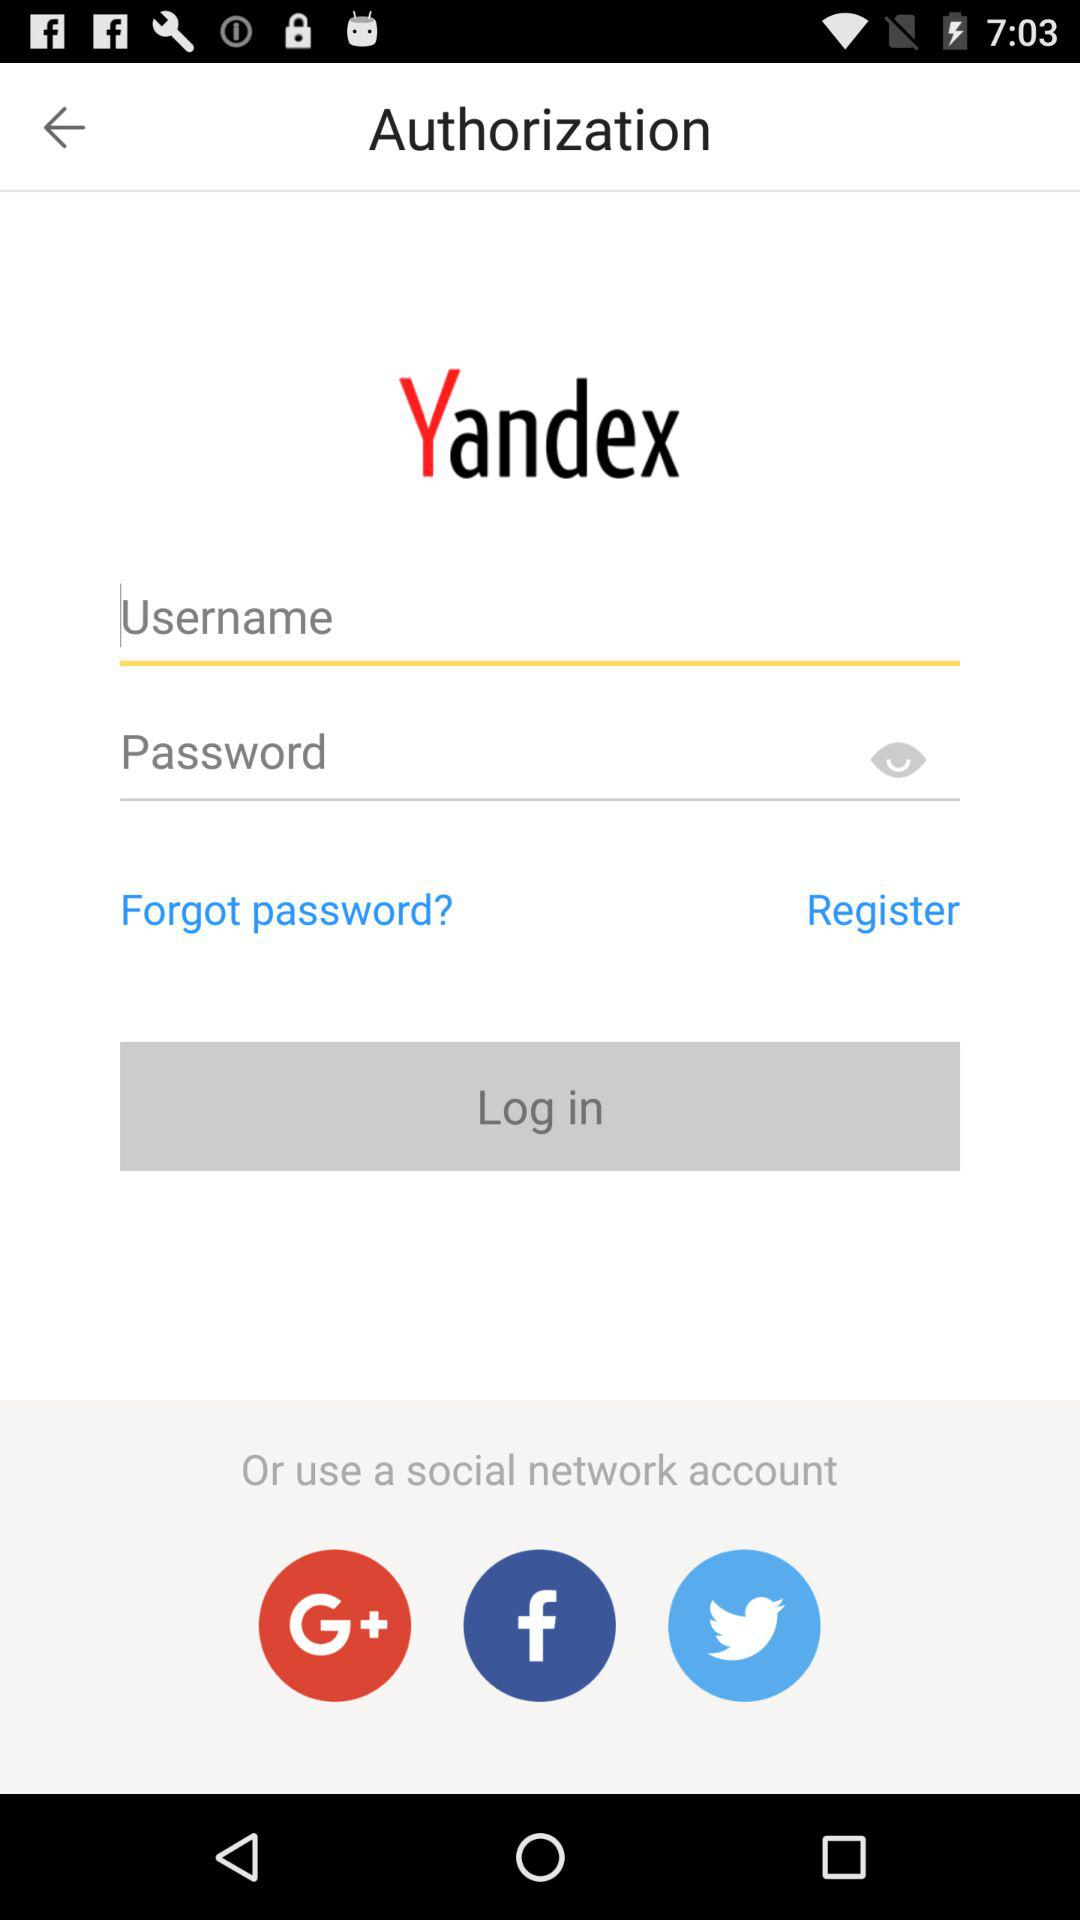How many social networks are available to log in with?
Answer the question using a single word or phrase. 3 